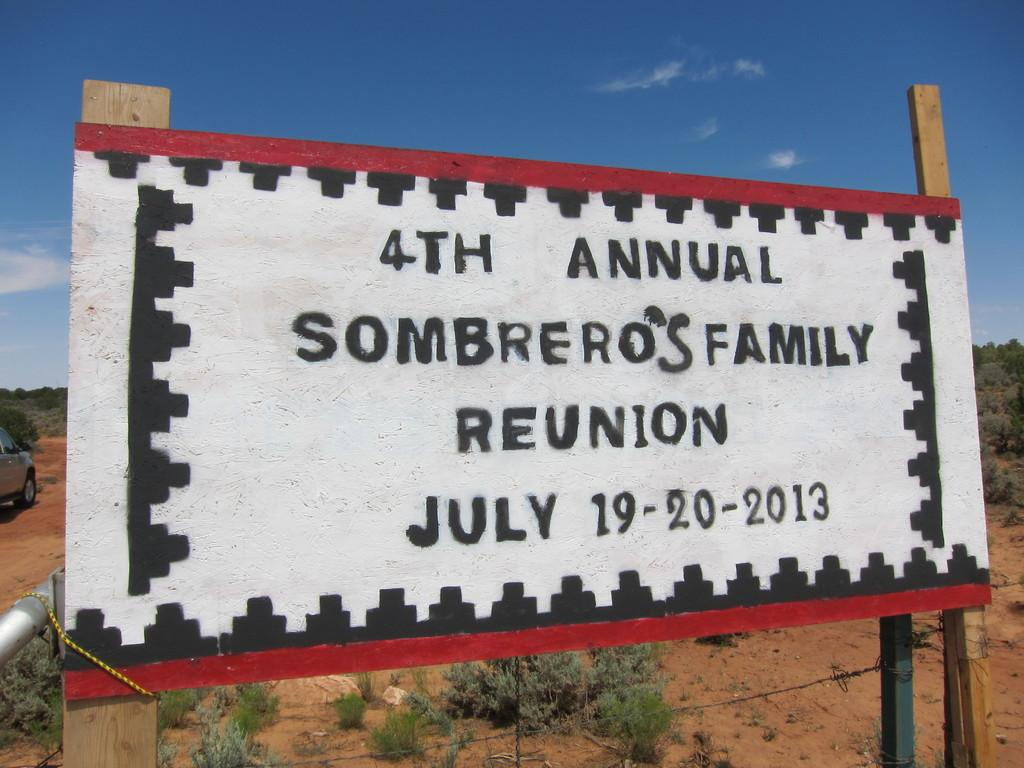Provide a one-sentence caption for the provided image. A billboard sits in scrubland and says 4th Annual Sombrero's family reunion July 19-20 2013. 